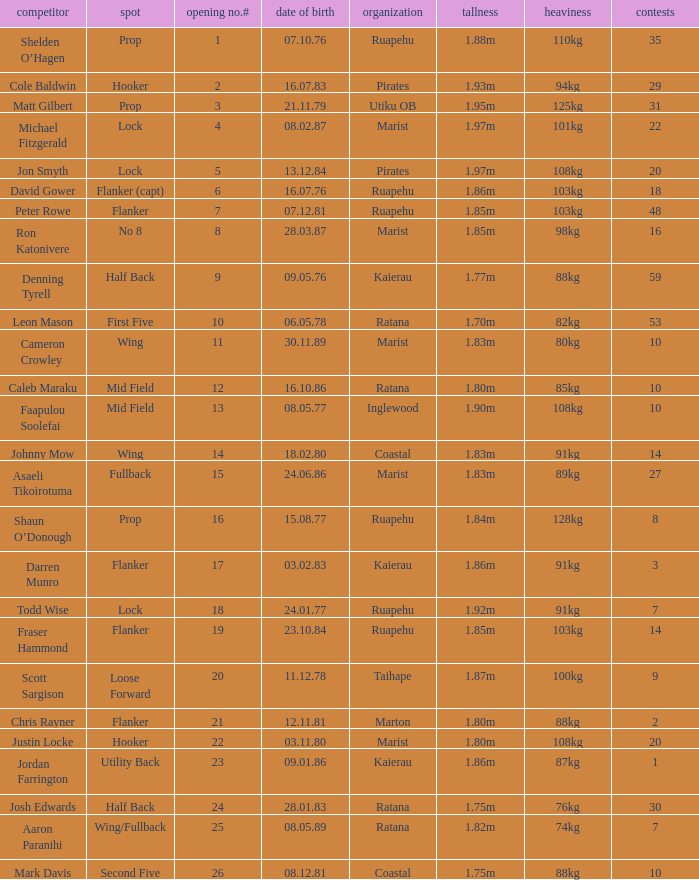What position does the player Todd Wise play in? Lock. 